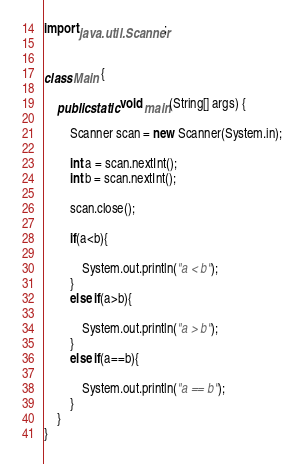Convert code to text. <code><loc_0><loc_0><loc_500><loc_500><_Java_>import java.util.Scanner;


class Main {

	public static void main(String[] args) {

		Scanner scan = new Scanner(System.in);

		int a = scan.nextInt();
		int b = scan.nextInt();

		scan.close();

		if(a<b){

			System.out.println("a < b");
		}
		else if(a>b){

			System.out.println("a > b");
		}
		else if(a==b){

			System.out.println("a == b");
		}
	}
}</code> 